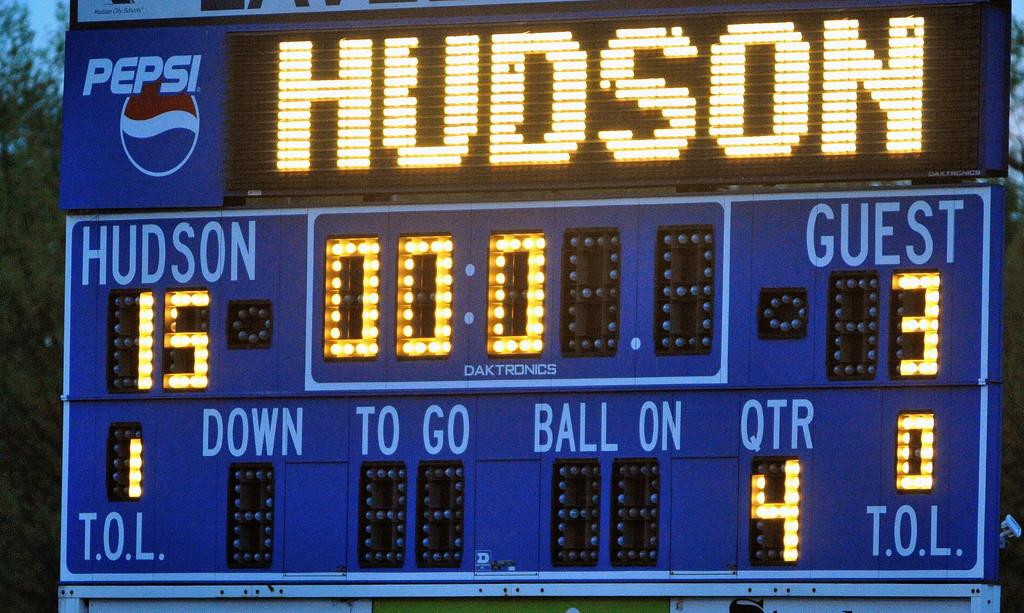<image>
Relay a brief, clear account of the picture shown. a scoreboard that had the word Hudson on it 